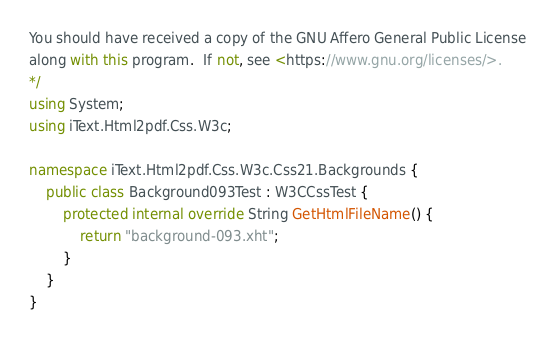Convert code to text. <code><loc_0><loc_0><loc_500><loc_500><_C#_>
You should have received a copy of the GNU Affero General Public License
along with this program.  If not, see <https://www.gnu.org/licenses/>.
*/
using System;
using iText.Html2pdf.Css.W3c;

namespace iText.Html2pdf.Css.W3c.Css21.Backgrounds {
    public class Background093Test : W3CCssTest {
        protected internal override String GetHtmlFileName() {
            return "background-093.xht";
        }
    }
}
</code> 